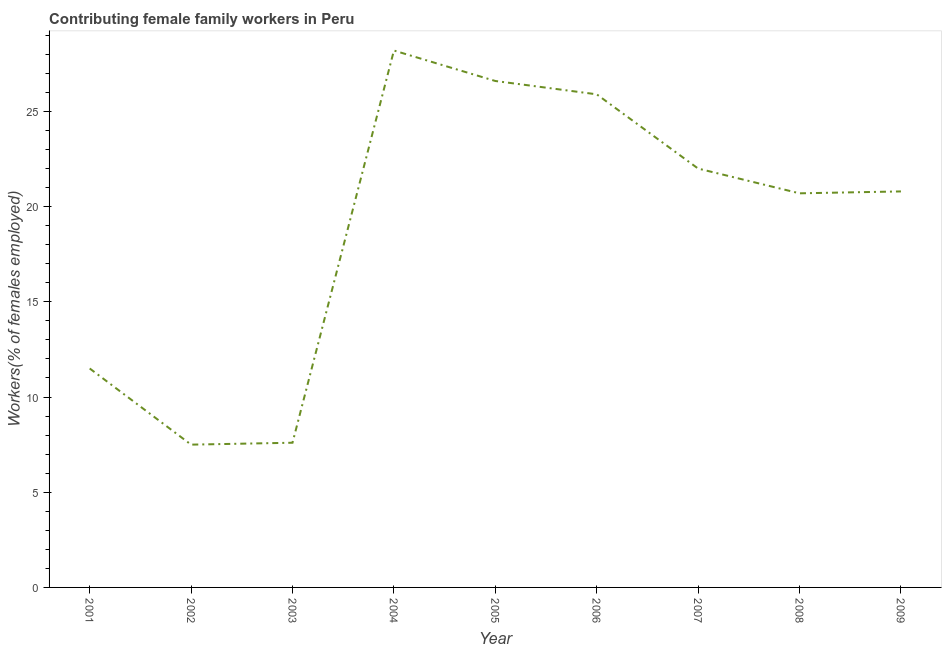Across all years, what is the maximum contributing female family workers?
Your answer should be very brief. 28.2. In which year was the contributing female family workers maximum?
Offer a very short reply. 2004. In which year was the contributing female family workers minimum?
Your response must be concise. 2002. What is the sum of the contributing female family workers?
Make the answer very short. 170.8. What is the difference between the contributing female family workers in 2003 and 2008?
Ensure brevity in your answer.  -13.1. What is the average contributing female family workers per year?
Keep it short and to the point. 18.98. What is the median contributing female family workers?
Your answer should be compact. 20.8. In how many years, is the contributing female family workers greater than 17 %?
Offer a terse response. 6. What is the ratio of the contributing female family workers in 2004 to that in 2009?
Make the answer very short. 1.36. Is the contributing female family workers in 2001 less than that in 2007?
Make the answer very short. Yes. Is the difference between the contributing female family workers in 2002 and 2006 greater than the difference between any two years?
Ensure brevity in your answer.  No. What is the difference between the highest and the second highest contributing female family workers?
Your answer should be compact. 1.6. What is the difference between the highest and the lowest contributing female family workers?
Give a very brief answer. 20.7. In how many years, is the contributing female family workers greater than the average contributing female family workers taken over all years?
Provide a short and direct response. 6. Does the contributing female family workers monotonically increase over the years?
Make the answer very short. No. How many lines are there?
Ensure brevity in your answer.  1. How many years are there in the graph?
Provide a succinct answer. 9. Does the graph contain grids?
Keep it short and to the point. No. What is the title of the graph?
Provide a short and direct response. Contributing female family workers in Peru. What is the label or title of the X-axis?
Your answer should be very brief. Year. What is the label or title of the Y-axis?
Keep it short and to the point. Workers(% of females employed). What is the Workers(% of females employed) in 2001?
Your answer should be compact. 11.5. What is the Workers(% of females employed) of 2003?
Offer a very short reply. 7.6. What is the Workers(% of females employed) in 2004?
Give a very brief answer. 28.2. What is the Workers(% of females employed) in 2005?
Provide a short and direct response. 26.6. What is the Workers(% of females employed) of 2006?
Offer a very short reply. 25.9. What is the Workers(% of females employed) of 2007?
Your response must be concise. 22. What is the Workers(% of females employed) in 2008?
Your answer should be very brief. 20.7. What is the Workers(% of females employed) of 2009?
Provide a short and direct response. 20.8. What is the difference between the Workers(% of females employed) in 2001 and 2004?
Your answer should be compact. -16.7. What is the difference between the Workers(% of females employed) in 2001 and 2005?
Offer a terse response. -15.1. What is the difference between the Workers(% of females employed) in 2001 and 2006?
Your answer should be compact. -14.4. What is the difference between the Workers(% of females employed) in 2001 and 2009?
Make the answer very short. -9.3. What is the difference between the Workers(% of females employed) in 2002 and 2003?
Offer a terse response. -0.1. What is the difference between the Workers(% of females employed) in 2002 and 2004?
Your answer should be very brief. -20.7. What is the difference between the Workers(% of females employed) in 2002 and 2005?
Provide a short and direct response. -19.1. What is the difference between the Workers(% of females employed) in 2002 and 2006?
Offer a terse response. -18.4. What is the difference between the Workers(% of females employed) in 2002 and 2007?
Offer a very short reply. -14.5. What is the difference between the Workers(% of females employed) in 2002 and 2008?
Make the answer very short. -13.2. What is the difference between the Workers(% of females employed) in 2002 and 2009?
Offer a very short reply. -13.3. What is the difference between the Workers(% of females employed) in 2003 and 2004?
Make the answer very short. -20.6. What is the difference between the Workers(% of females employed) in 2003 and 2006?
Your answer should be compact. -18.3. What is the difference between the Workers(% of females employed) in 2003 and 2007?
Offer a very short reply. -14.4. What is the difference between the Workers(% of females employed) in 2004 and 2005?
Keep it short and to the point. 1.6. What is the difference between the Workers(% of females employed) in 2004 and 2006?
Provide a short and direct response. 2.3. What is the difference between the Workers(% of females employed) in 2005 and 2007?
Provide a short and direct response. 4.6. What is the difference between the Workers(% of females employed) in 2005 and 2008?
Keep it short and to the point. 5.9. What is the difference between the Workers(% of females employed) in 2005 and 2009?
Keep it short and to the point. 5.8. What is the difference between the Workers(% of females employed) in 2006 and 2007?
Keep it short and to the point. 3.9. What is the difference between the Workers(% of females employed) in 2006 and 2008?
Make the answer very short. 5.2. What is the difference between the Workers(% of females employed) in 2007 and 2008?
Your answer should be very brief. 1.3. What is the difference between the Workers(% of females employed) in 2007 and 2009?
Make the answer very short. 1.2. What is the ratio of the Workers(% of females employed) in 2001 to that in 2002?
Provide a succinct answer. 1.53. What is the ratio of the Workers(% of females employed) in 2001 to that in 2003?
Your answer should be compact. 1.51. What is the ratio of the Workers(% of females employed) in 2001 to that in 2004?
Your answer should be compact. 0.41. What is the ratio of the Workers(% of females employed) in 2001 to that in 2005?
Provide a succinct answer. 0.43. What is the ratio of the Workers(% of females employed) in 2001 to that in 2006?
Your response must be concise. 0.44. What is the ratio of the Workers(% of females employed) in 2001 to that in 2007?
Make the answer very short. 0.52. What is the ratio of the Workers(% of females employed) in 2001 to that in 2008?
Your answer should be very brief. 0.56. What is the ratio of the Workers(% of females employed) in 2001 to that in 2009?
Give a very brief answer. 0.55. What is the ratio of the Workers(% of females employed) in 2002 to that in 2003?
Offer a terse response. 0.99. What is the ratio of the Workers(% of females employed) in 2002 to that in 2004?
Provide a short and direct response. 0.27. What is the ratio of the Workers(% of females employed) in 2002 to that in 2005?
Your answer should be very brief. 0.28. What is the ratio of the Workers(% of females employed) in 2002 to that in 2006?
Provide a succinct answer. 0.29. What is the ratio of the Workers(% of females employed) in 2002 to that in 2007?
Give a very brief answer. 0.34. What is the ratio of the Workers(% of females employed) in 2002 to that in 2008?
Keep it short and to the point. 0.36. What is the ratio of the Workers(% of females employed) in 2002 to that in 2009?
Your response must be concise. 0.36. What is the ratio of the Workers(% of females employed) in 2003 to that in 2004?
Keep it short and to the point. 0.27. What is the ratio of the Workers(% of females employed) in 2003 to that in 2005?
Your answer should be compact. 0.29. What is the ratio of the Workers(% of females employed) in 2003 to that in 2006?
Make the answer very short. 0.29. What is the ratio of the Workers(% of females employed) in 2003 to that in 2007?
Offer a terse response. 0.34. What is the ratio of the Workers(% of females employed) in 2003 to that in 2008?
Your answer should be very brief. 0.37. What is the ratio of the Workers(% of females employed) in 2003 to that in 2009?
Ensure brevity in your answer.  0.36. What is the ratio of the Workers(% of females employed) in 2004 to that in 2005?
Offer a very short reply. 1.06. What is the ratio of the Workers(% of females employed) in 2004 to that in 2006?
Keep it short and to the point. 1.09. What is the ratio of the Workers(% of females employed) in 2004 to that in 2007?
Provide a succinct answer. 1.28. What is the ratio of the Workers(% of females employed) in 2004 to that in 2008?
Offer a very short reply. 1.36. What is the ratio of the Workers(% of females employed) in 2004 to that in 2009?
Make the answer very short. 1.36. What is the ratio of the Workers(% of females employed) in 2005 to that in 2006?
Offer a terse response. 1.03. What is the ratio of the Workers(% of females employed) in 2005 to that in 2007?
Offer a very short reply. 1.21. What is the ratio of the Workers(% of females employed) in 2005 to that in 2008?
Provide a short and direct response. 1.28. What is the ratio of the Workers(% of females employed) in 2005 to that in 2009?
Provide a succinct answer. 1.28. What is the ratio of the Workers(% of females employed) in 2006 to that in 2007?
Your answer should be very brief. 1.18. What is the ratio of the Workers(% of females employed) in 2006 to that in 2008?
Offer a very short reply. 1.25. What is the ratio of the Workers(% of females employed) in 2006 to that in 2009?
Ensure brevity in your answer.  1.25. What is the ratio of the Workers(% of females employed) in 2007 to that in 2008?
Offer a very short reply. 1.06. What is the ratio of the Workers(% of females employed) in 2007 to that in 2009?
Provide a succinct answer. 1.06. What is the ratio of the Workers(% of females employed) in 2008 to that in 2009?
Your response must be concise. 0.99. 